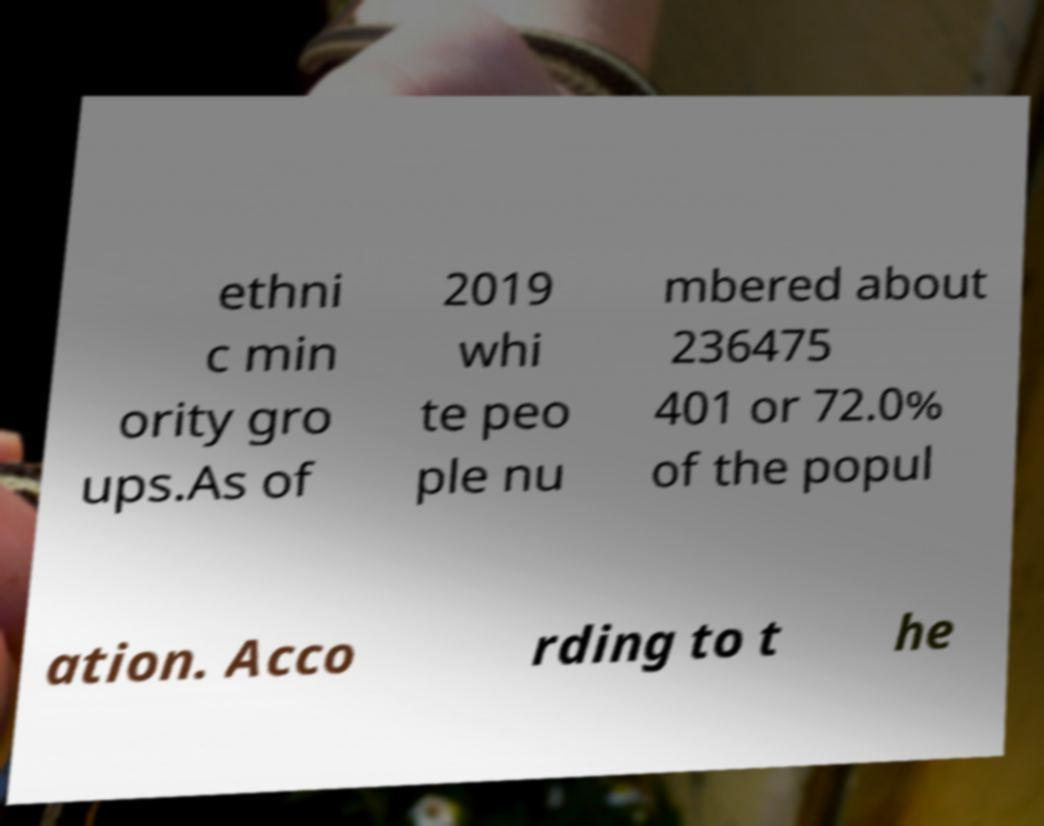Could you assist in decoding the text presented in this image and type it out clearly? ethni c min ority gro ups.As of 2019 whi te peo ple nu mbered about 236475 401 or 72.0% of the popul ation. Acco rding to t he 